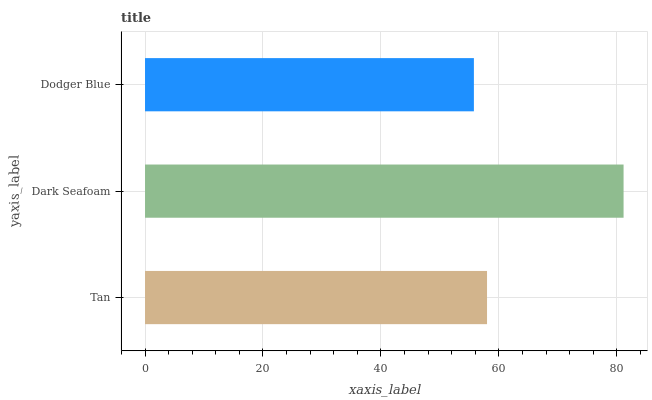Is Dodger Blue the minimum?
Answer yes or no. Yes. Is Dark Seafoam the maximum?
Answer yes or no. Yes. Is Dark Seafoam the minimum?
Answer yes or no. No. Is Dodger Blue the maximum?
Answer yes or no. No. Is Dark Seafoam greater than Dodger Blue?
Answer yes or no. Yes. Is Dodger Blue less than Dark Seafoam?
Answer yes or no. Yes. Is Dodger Blue greater than Dark Seafoam?
Answer yes or no. No. Is Dark Seafoam less than Dodger Blue?
Answer yes or no. No. Is Tan the high median?
Answer yes or no. Yes. Is Tan the low median?
Answer yes or no. Yes. Is Dodger Blue the high median?
Answer yes or no. No. Is Dodger Blue the low median?
Answer yes or no. No. 